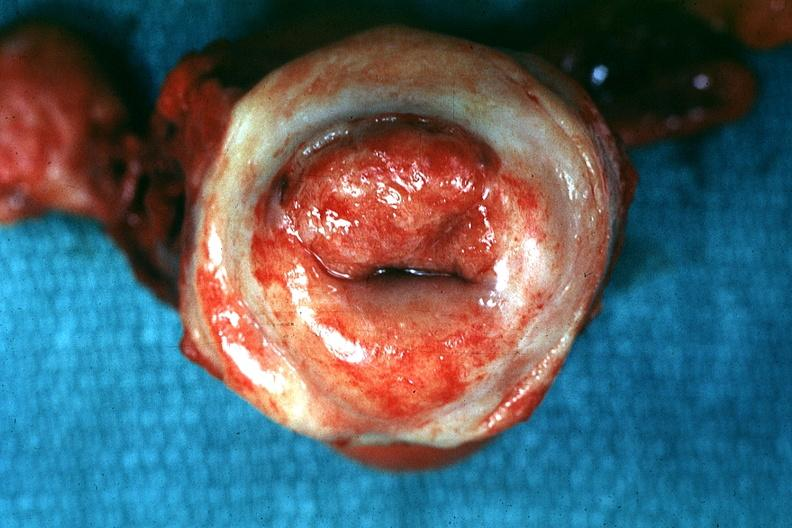where does this belong to?
Answer the question using a single word or phrase. Female reproductive system 